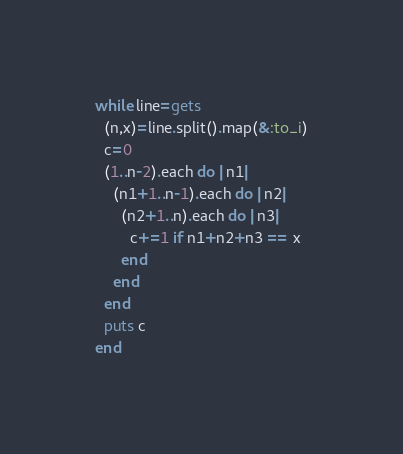Convert code to text. <code><loc_0><loc_0><loc_500><loc_500><_Ruby_>while line=gets
  (n,x)=line.split().map(&:to_i)
  c=0
  (1..n-2).each do |n1|
    (n1+1..n-1).each do |n2|
      (n2+1..n).each do |n3|
        c+=1 if n1+n2+n3 == x
      end
    end
  end
  puts c
end</code> 